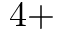<formula> <loc_0><loc_0><loc_500><loc_500>4 +</formula> 